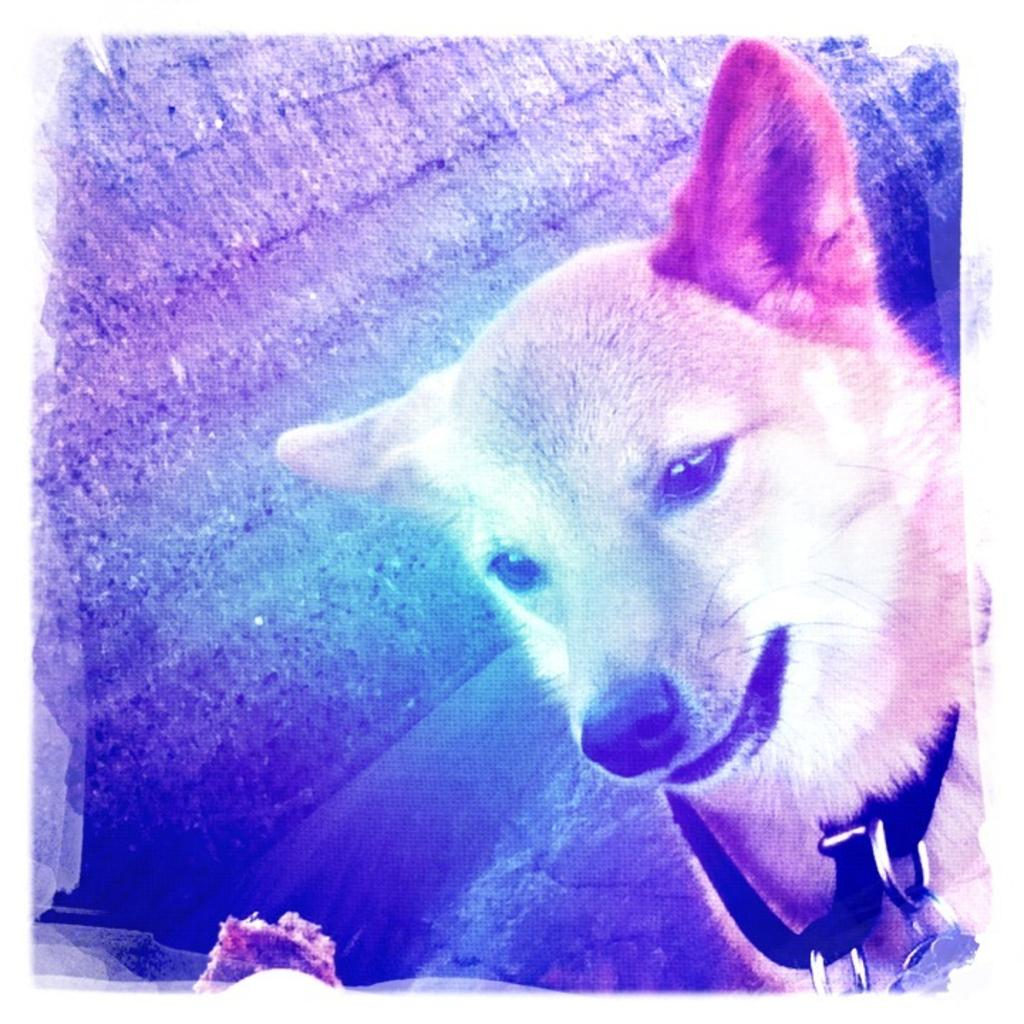What animal is present in the image? There is a dog in the image. Is there anything around the dog's neck? Yes, the dog has a belt around its neck. On which side of the image is the dog located? The dog is on the right side of the image. How would you describe the background of the image? The background of the image has multiple colors. What type of pig can be seen in the image? There is no pig present in the image. 